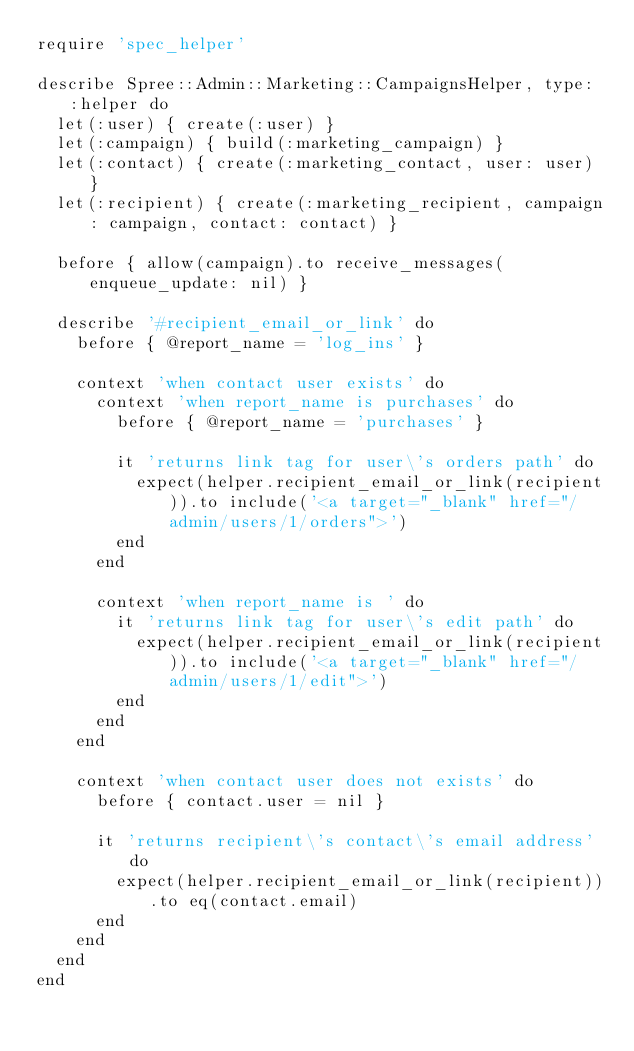<code> <loc_0><loc_0><loc_500><loc_500><_Ruby_>require 'spec_helper'

describe Spree::Admin::Marketing::CampaignsHelper, type: :helper do
  let(:user) { create(:user) }
  let(:campaign) { build(:marketing_campaign) }
  let(:contact) { create(:marketing_contact, user: user) }
  let(:recipient) { create(:marketing_recipient, campaign: campaign, contact: contact) }

  before { allow(campaign).to receive_messages(enqueue_update: nil) }

  describe '#recipient_email_or_link' do
    before { @report_name = 'log_ins' }

    context 'when contact user exists' do
      context 'when report_name is purchases' do
        before { @report_name = 'purchases' }

        it 'returns link tag for user\'s orders path' do
          expect(helper.recipient_email_or_link(recipient)).to include('<a target="_blank" href="/admin/users/1/orders">')
        end
      end

      context 'when report_name is ' do
        it 'returns link tag for user\'s edit path' do
          expect(helper.recipient_email_or_link(recipient)).to include('<a target="_blank" href="/admin/users/1/edit">')
        end
      end
    end

    context 'when contact user does not exists' do
      before { contact.user = nil }

      it 'returns recipient\'s contact\'s email address' do
        expect(helper.recipient_email_or_link(recipient)).to eq(contact.email)
      end
    end
  end
end
</code> 